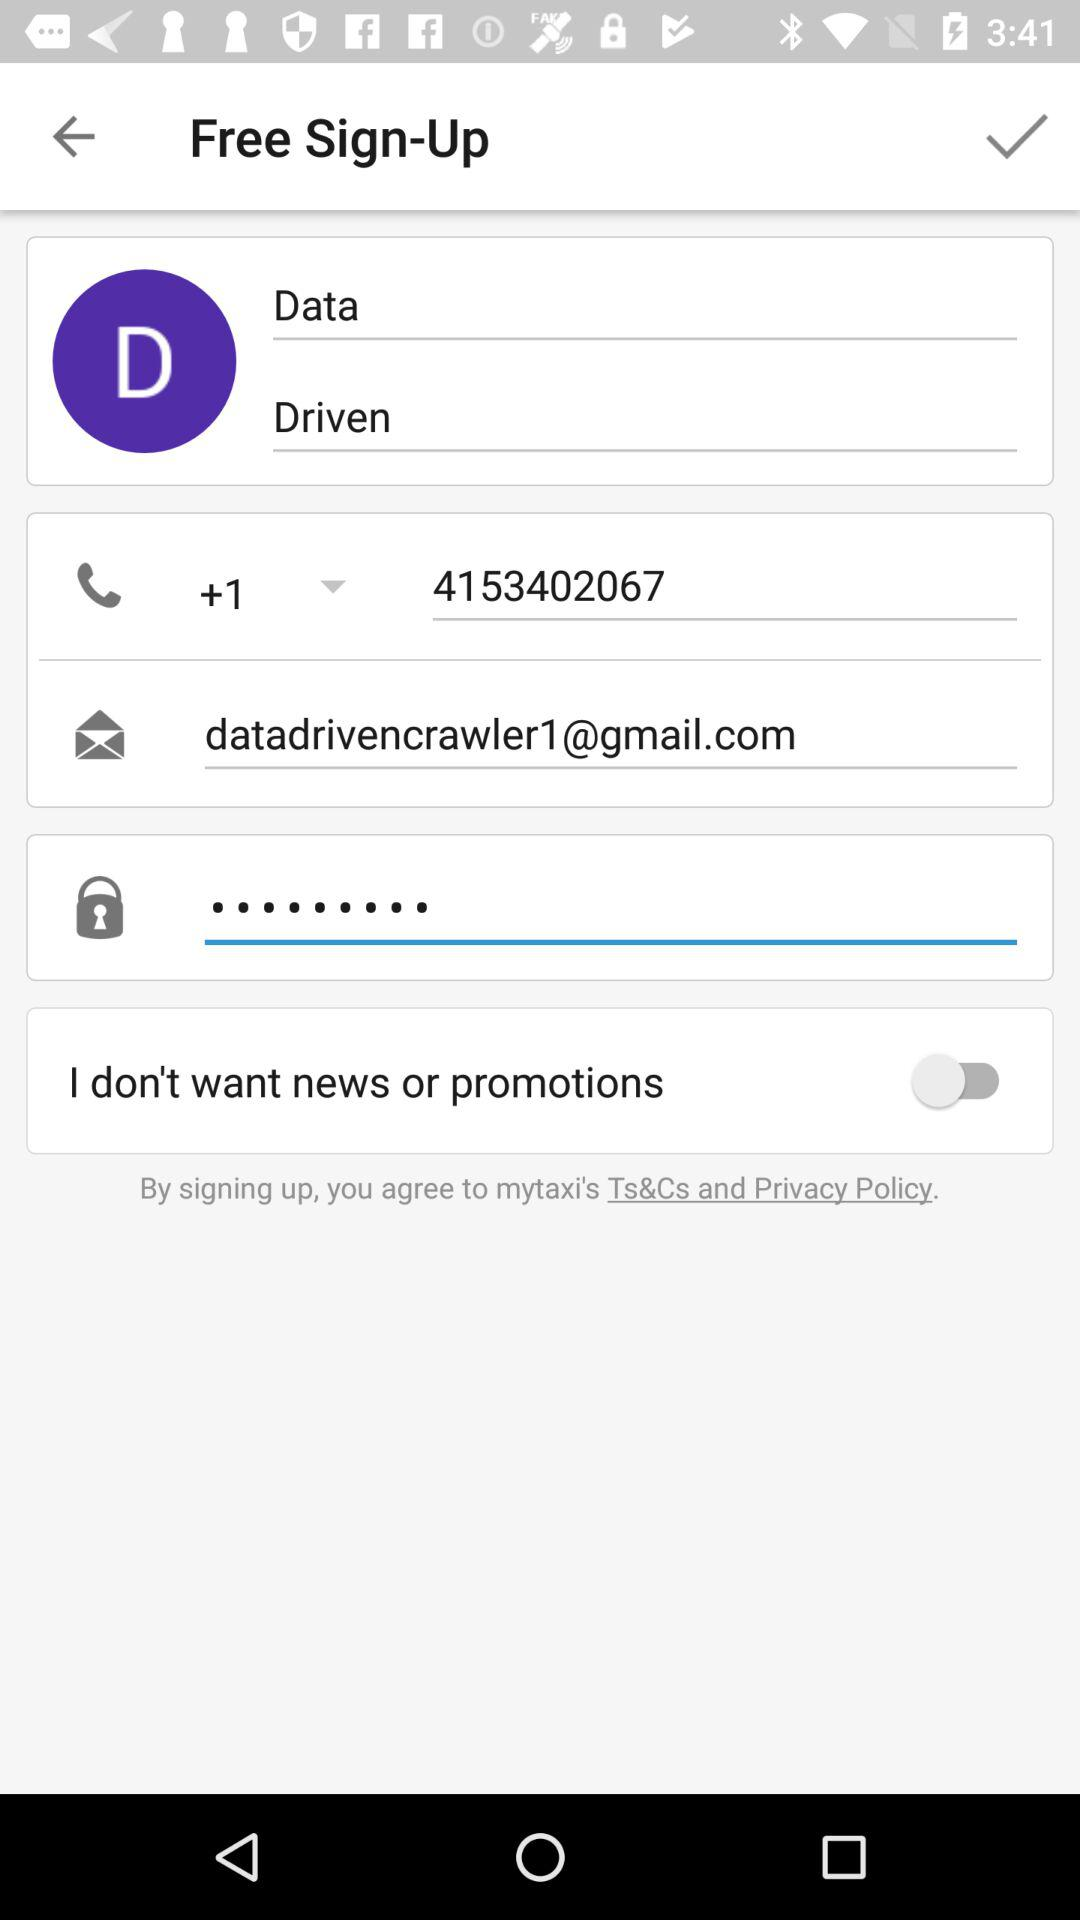What is the status of the "I don't want news or promotions"? The status of the "I don't want news or promotions" is "off". 